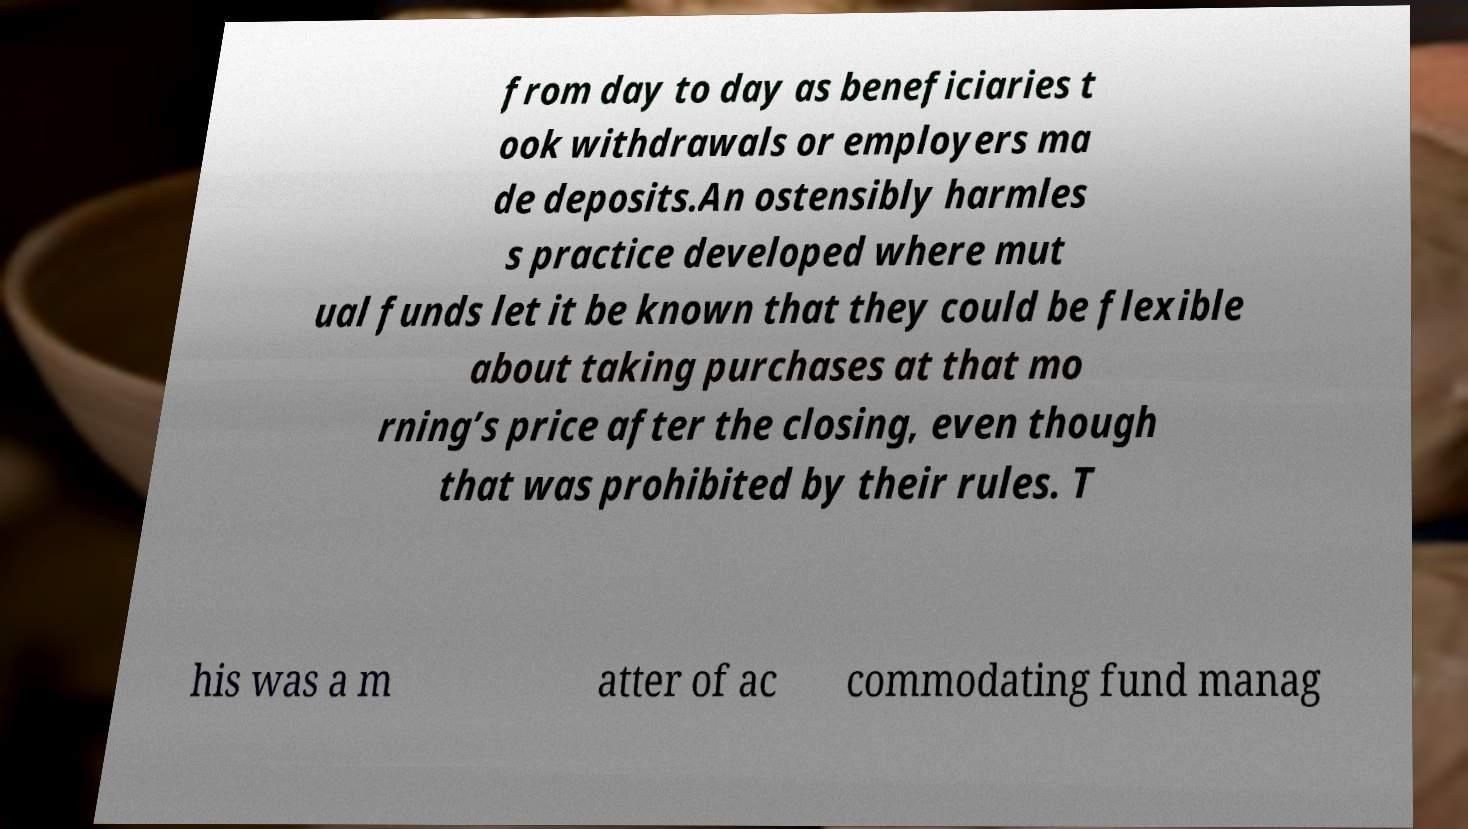Could you extract and type out the text from this image? from day to day as beneficiaries t ook withdrawals or employers ma de deposits.An ostensibly harmles s practice developed where mut ual funds let it be known that they could be flexible about taking purchases at that mo rning’s price after the closing, even though that was prohibited by their rules. T his was a m atter of ac commodating fund manag 